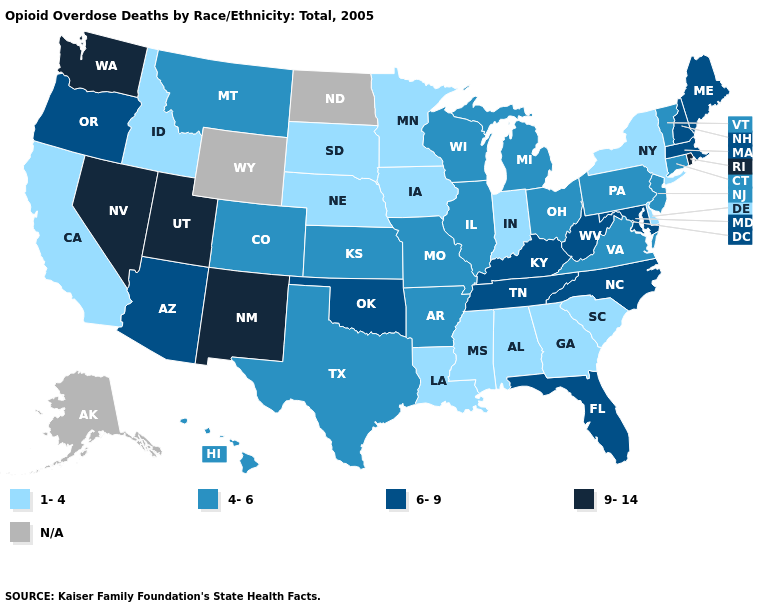What is the lowest value in the USA?
Write a very short answer. 1-4. Does South Dakota have the highest value in the USA?
Give a very brief answer. No. Does the map have missing data?
Short answer required. Yes. Does Wisconsin have the highest value in the MidWest?
Short answer required. Yes. What is the value of Wyoming?
Keep it brief. N/A. Name the states that have a value in the range 4-6?
Keep it brief. Arkansas, Colorado, Connecticut, Hawaii, Illinois, Kansas, Michigan, Missouri, Montana, New Jersey, Ohio, Pennsylvania, Texas, Vermont, Virginia, Wisconsin. Does Iowa have the highest value in the USA?
Concise answer only. No. What is the value of Texas?
Answer briefly. 4-6. Name the states that have a value in the range 1-4?
Concise answer only. Alabama, California, Delaware, Georgia, Idaho, Indiana, Iowa, Louisiana, Minnesota, Mississippi, Nebraska, New York, South Carolina, South Dakota. Among the states that border Arizona , does California have the highest value?
Answer briefly. No. How many symbols are there in the legend?
Write a very short answer. 5. Does North Carolina have the lowest value in the South?
Answer briefly. No. Does Mississippi have the lowest value in the USA?
Quick response, please. Yes. Which states have the highest value in the USA?
Quick response, please. Nevada, New Mexico, Rhode Island, Utah, Washington. 